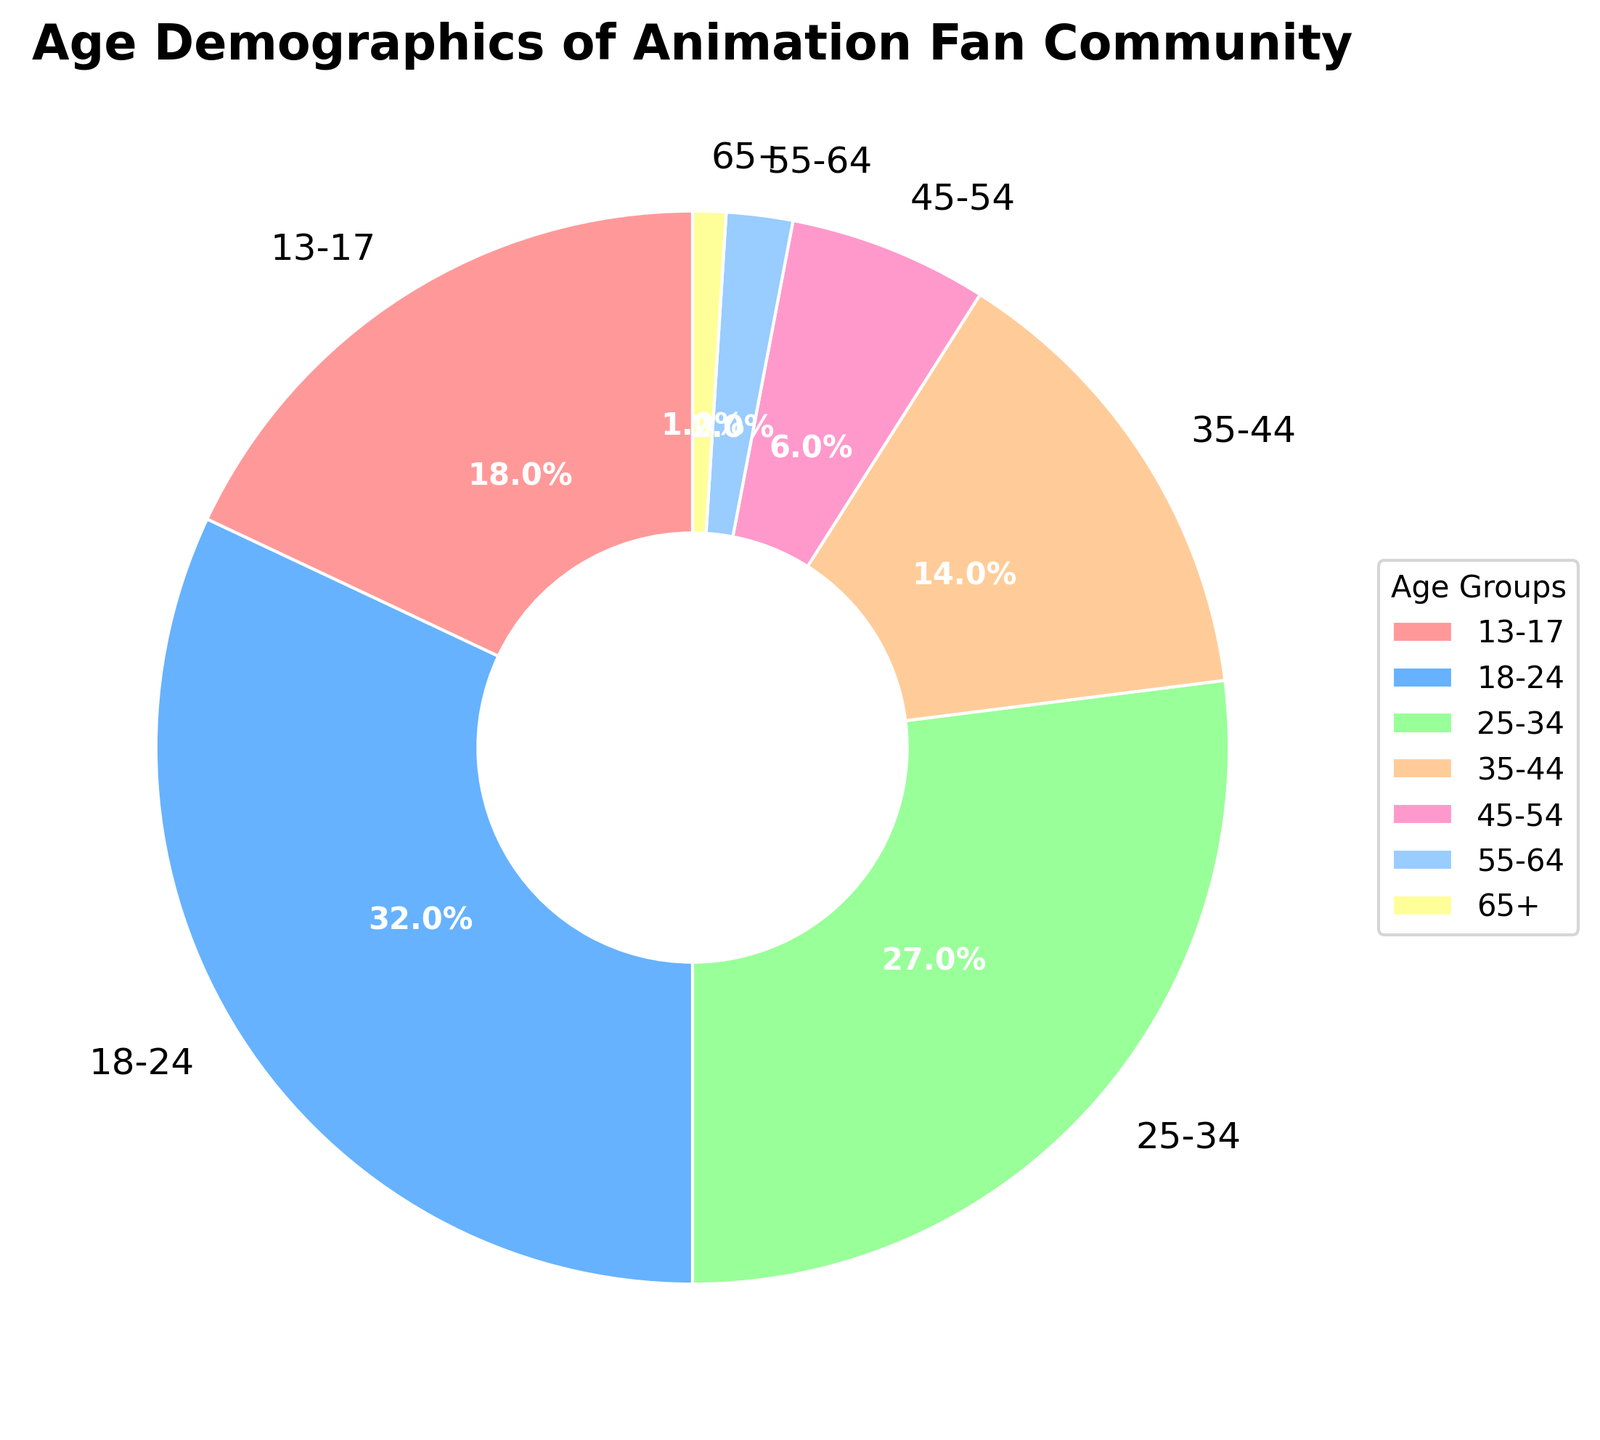What percentage of the community is between the ages of 18 and 34? To determine the percentage of the community between 18 and 34, we sum the percentages of the 18-24 and 25-34 age groups: 32% + 27% = 59%
Answer: 59% Which age group represents the smallest percentage of the community? The age group with the smallest percentage is 65+ with 1% based on the figure.
Answer: 65+ What is the difference in percentage between the 18-24 age group and the 35-44 age group? We subtract the percentage of the 35-44 age group (14%) from the percentage of the 18-24 age group (32%): 32% - 14% = 18%
Answer: 18% Which age groups combined make up more than half of the community? By combining the percentages of the age groups until the sum exceeds 50%, the 18-24 group (32%) and the 25-34 group (27%) together make up 59%, which is more than half of the community.
Answer: 18-24 and 25-34 How many age groups have a percentage of 10% or more? By examining the provided percentages, there are four age groups with 10% or more: 13-17 (18%), 18-24 (32%), 25-34 (27%), and 35-44 (14%).
Answer: 4 What percentage of the community is over the age of 44? We add the percentages of the 45-54, 55-64, and 65+ age groups: 6% + 2% + 1% = 9%
Answer: 9% Which age group is represented by a blue wedge in the pie chart? The colors used in the pie chart are in the order from the data. The second color (blue) corresponds to the 18-24 age group.
Answer: 18-24 What is the combined percentage of the youngest (13-17) and oldest (65+) age groups? We add the percentages of the 13-17 and 65+ age groups: 18% + 1% = 19%
Answer: 19% Is the percentage of the community in the 25-34 age group more or less than double that of the 35-44 age group? The percentage of the 25-34 age group is 27%, and double the 35-44 age group's percentage is 14% * 2 = 28%. Hence, 27% is slightly less than 28%.
Answer: Less 